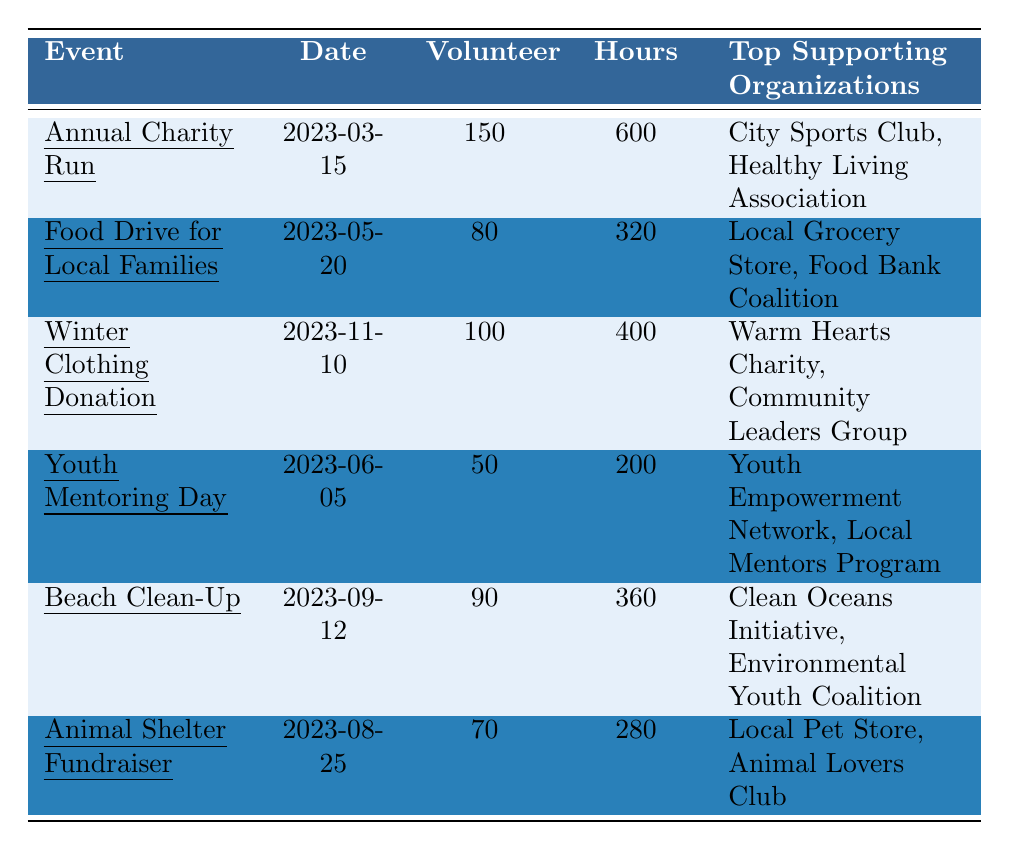What is the total number of volunteers for all events? The number of volunteers for each event is as follows: Annual Charity Run (150), Food Drive for Local Families (80), Winter Clothing Donation (100), Youth Mentoring Day (50), Beach Clean-Up (90), Animal Shelter Fundraiser (70). Summing these gives 150 + 80 + 100 + 50 + 90 + 70 = 540.
Answer: 540 Which event had the highest number of hours contributed by volunteers? Analyzing the hours contributed: Annual Charity Run (600), Food Drive for Local Families (320), Winter Clothing Donation (400), Youth Mentoring Day (200), Beach Clean-Up (360), Animal Shelter Fundraiser (280). The highest is 600 hours from the Annual Charity Run.
Answer: Annual Charity Run What is the total number of items collected in the Food Drive and Winter Clothing Donation? The items collected are 5000 in the Food Drive for Local Families and 1200 in the Winter Clothing Donation. Adding these values gives 5000 + 1200 = 6200.
Answer: 6200 How many volunteers participated in the Youth Mentoring Day and Beach Clean-Up combined? The number of volunteers for Youth Mentoring Day is 50, and for Beach Clean-Up is 90. Combining these gives 50 + 90 = 140 volunteers.
Answer: 140 Did the Animal Shelter Fundraiser raise more or less than the Winter Clothing Donation? The Animal Shelter Fundraiser raised 15000, and the Winter Clothing Donation did not raise funds, so it raised 0. Therefore, it raised more than 0.
Answer: More Which event involved the most organizations as top supporters? The Annual Charity Run and Food Drive for Local Families each listed 2 top supporting organizations. The other events also have 2 or fewer. None had more than 2.
Answer: Two How many total hours were contributed across all events? The hours contributed for each event are: Annual Charity Run (600), Food Drive for Local Families (320), Winter Clothing Donation (400), Youth Mentoring Day (200), Beach Clean-Up (360), and Animal Shelter Fundraiser (280). Summing them, 600 + 320 + 400 + 200 + 360 + 280 = 2160 hours.
Answer: 2160 What is the average number of volunteers per event? There were 6 events, and the total number of volunteers is 540. Calculating the average, 540 ÷ 6 = 90.
Answer: 90 If we consider only events with funds raised, what is the total amount raised? The events that raised funds are Annual Charity Run (25000) and Animal Shelter Fundraiser (15000). Adding these amounts gives 25000 + 15000 = 40000.
Answer: 40000 Which event has the least number of volunteers, and how many were there? The event with the least volunteers is Youth Mentoring Day with 50 volunteers.
Answer: Youth Mentoring Day, 50 What percentage of the total hours came from the Annual Charity Run? The total hours contributed is 2160, and the Annual Charity Run contributed 600 hours. The percentage calculation is (600 ÷ 2160) × 100 = 27.78%.
Answer: 27.78% 